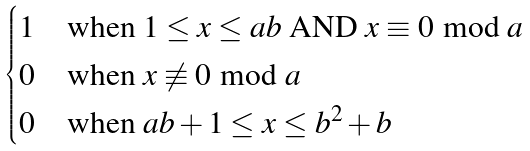Convert formula to latex. <formula><loc_0><loc_0><loc_500><loc_500>\begin{cases} 1 & \text {when $1 \leq x \leq ab$ AND $x \equiv 0\bmod{a}$} \\ 0 & \text {when $x \not\equiv 0\bmod{a}$} \\ 0 & \text {when $ab + 1 \leq x \leq b^{2} + b$} \\ \end{cases}</formula> 